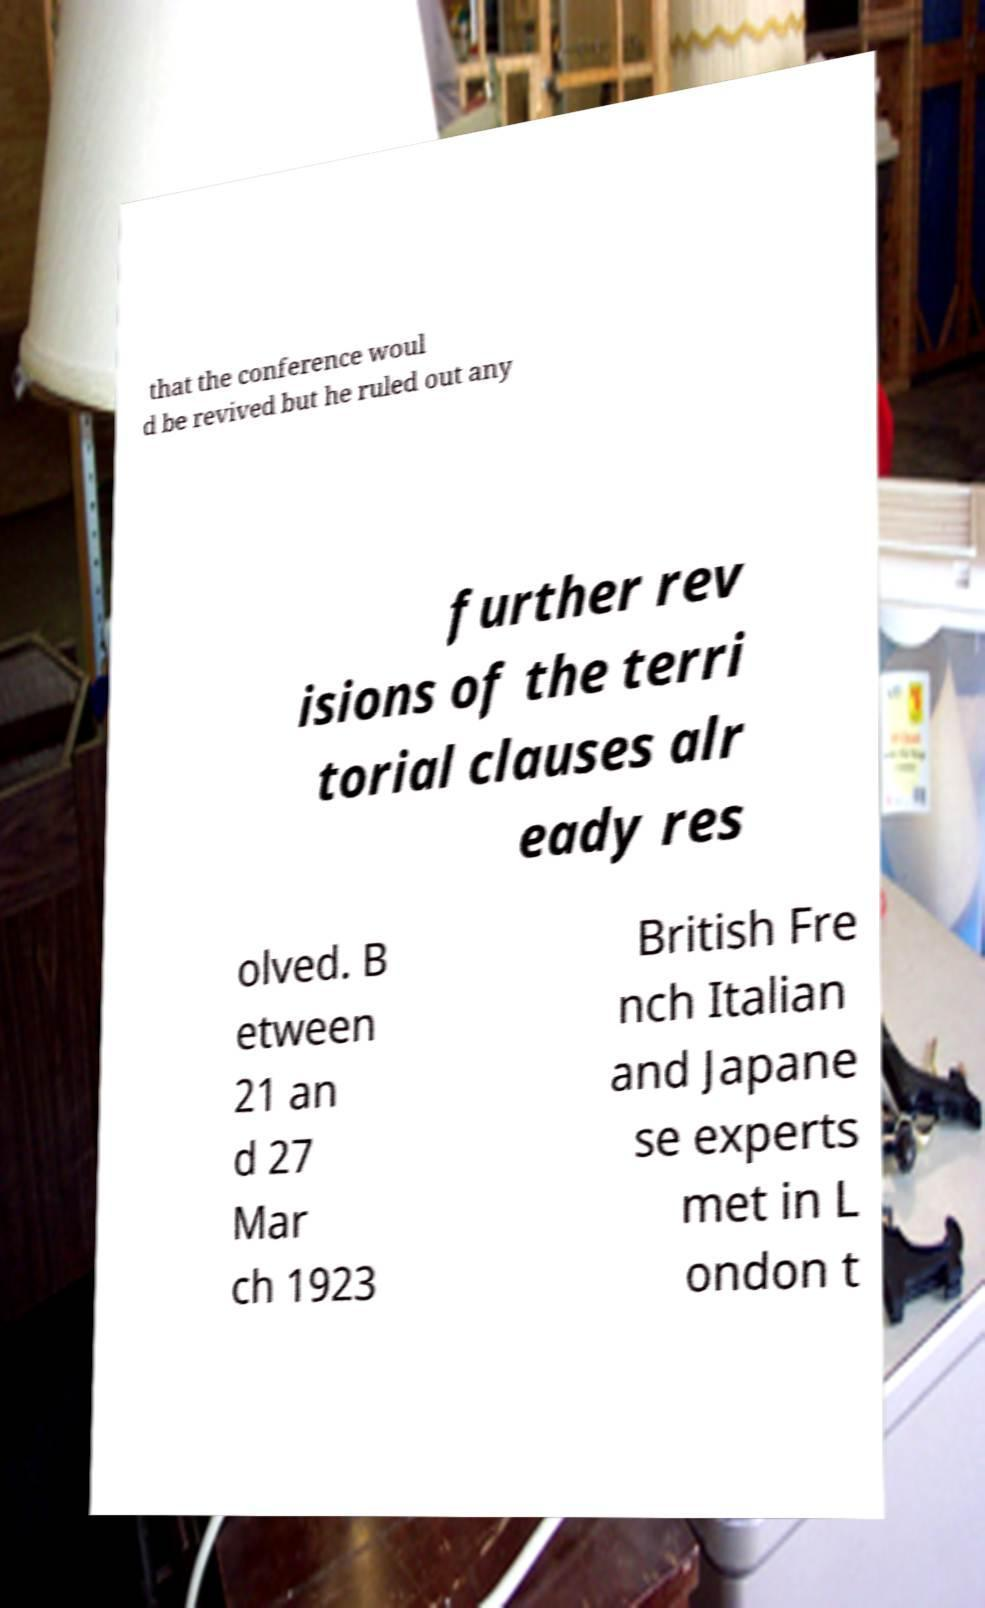Please identify and transcribe the text found in this image. that the conference woul d be revived but he ruled out any further rev isions of the terri torial clauses alr eady res olved. B etween 21 an d 27 Mar ch 1923 British Fre nch Italian and Japane se experts met in L ondon t 